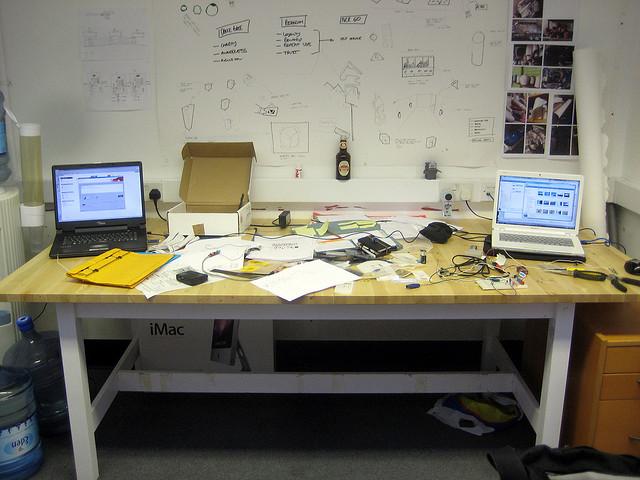What are sitting on the floor to the far left?
Be succinct. Water bottles. Are there magazines on the desk?
Write a very short answer. No. How many computers?
Give a very brief answer. 2. Is there a sticker on either laptop?
Be succinct. No. What is on the far left on the board?
Keep it brief. Drawings. What kind of beverage does the bottle hold?
Concise answer only. Beer. Is someone working here?
Be succinct. Yes. How many laptops are on the table?
Write a very short answer. 2. Is this picture cluttered?
Quick response, please. Yes. 